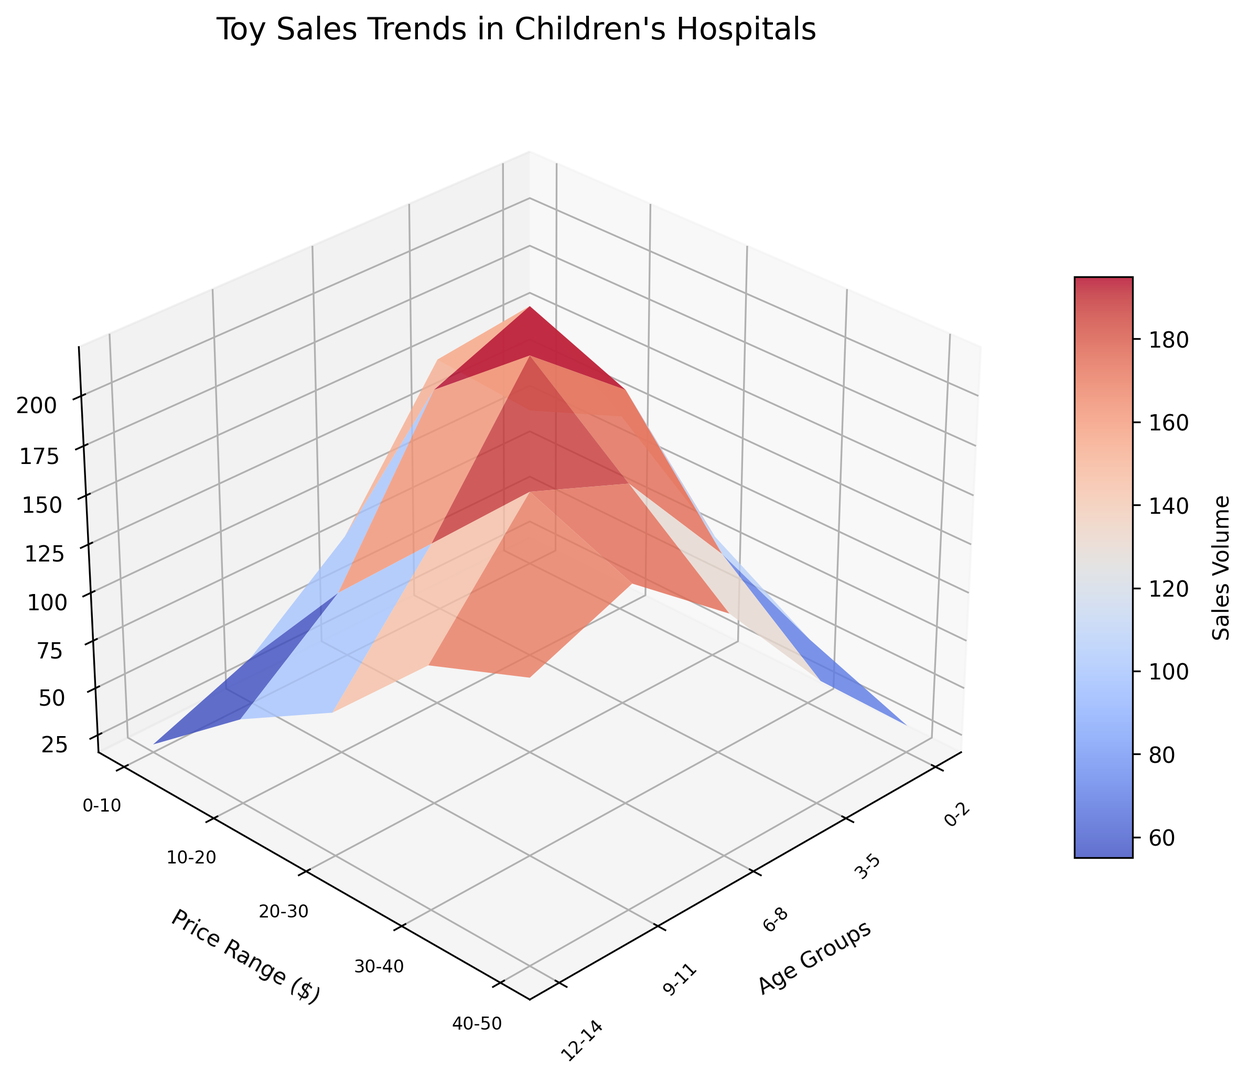Which age group has the highest toy sales volume in the $0-$10 price range? To find the highest sales volume in the $0-$10 price range, look at the corresponding bars for each age group. The age group with the tallest bar within this price range indicates the highest sales.
Answer: 3-5 What's the total sales volume for the 12-14 age group? Add the sales volumes for all price ranges within the 12-14 age group: 30 (0-10) + 80 (10-20) + 140 (20-30) + 180 (30-40) + 160 (40-50).
Answer: 590 Which price range has the highest sales volume for the 6-8 age group? Find the highest bar in the column corresponding to the 6-8 age group. The price range associated with this bar indicates the highest sales.
Answer: $20-$30 For the 9-11 age group, compare the sales volumes between the $30-$40 and $40-$50 price ranges. Which one is higher? Look at the height of the bars for the $30-$40 and $40-$50 price ranges within the 9-11 age group. The taller bar represents the higher sales volume.
Answer: $30-$40 What's the difference in sales volume between the $10-$20 and $30-$40 price ranges for the age group 3-5? Subtract the sales volume of the $30-$40 price range from the $10-$20 price range within the 3-5 age group: 200 (10-20) - 100 (30-40).
Answer: 100 What color on the plot represents higher sales volumes, and for which age group in the $20-$30 price range is this most prominent? Higher sales volumes are represented by the "coolwarm" color gradient, where warmer colors (closer to red) indicate higher volumes. Find the warmest color in the $20-$30 price range.
Answer: 6-8 Which age group has the lowest sales volume in the $40-$50 price range? Check the height of the bars in the $40-$50 price range for all age groups. The age group with the shortest bar represents the lowest sales volume.
Answer: 0-2 What's the average sales volume for all age groups in the $20-$30 price range? Add the sales volumes for all age groups in the $20-$30 price range and divide by the number of age groups: (80 + 180 + 220 + 180 + 140) / 5.
Answer: 160 